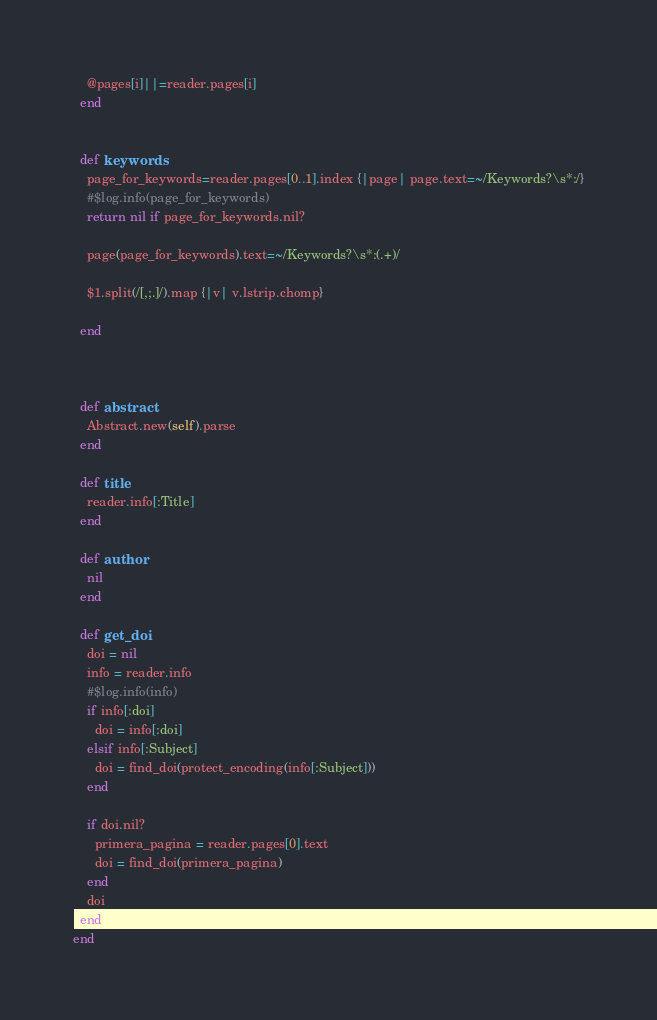<code> <loc_0><loc_0><loc_500><loc_500><_Ruby_>    @pages[i]||=reader.pages[i]
  end


  def keywords
    page_for_keywords=reader.pages[0..1].index {|page| page.text=~/Keywords?\s*:/}
    #$log.info(page_for_keywords)
    return nil if page_for_keywords.nil?

    page(page_for_keywords).text=~/Keywords?\s*:(.+)/

    $1.split(/[,;.]/).map {|v| v.lstrip.chomp}

  end



  def abstract
    Abstract.new(self).parse
  end

  def title
    reader.info[:Title]
  end

  def author
    nil
  end

  def get_doi
    doi = nil
    info = reader.info
    #$log.info(info)
    if info[:doi]
      doi = info[:doi]
    elsif info[:Subject]
      doi = find_doi(protect_encoding(info[:Subject]))
    end

    if doi.nil?
      primera_pagina = reader.pages[0].text
      doi = find_doi(primera_pagina)
    end
    doi
  end
end
</code> 